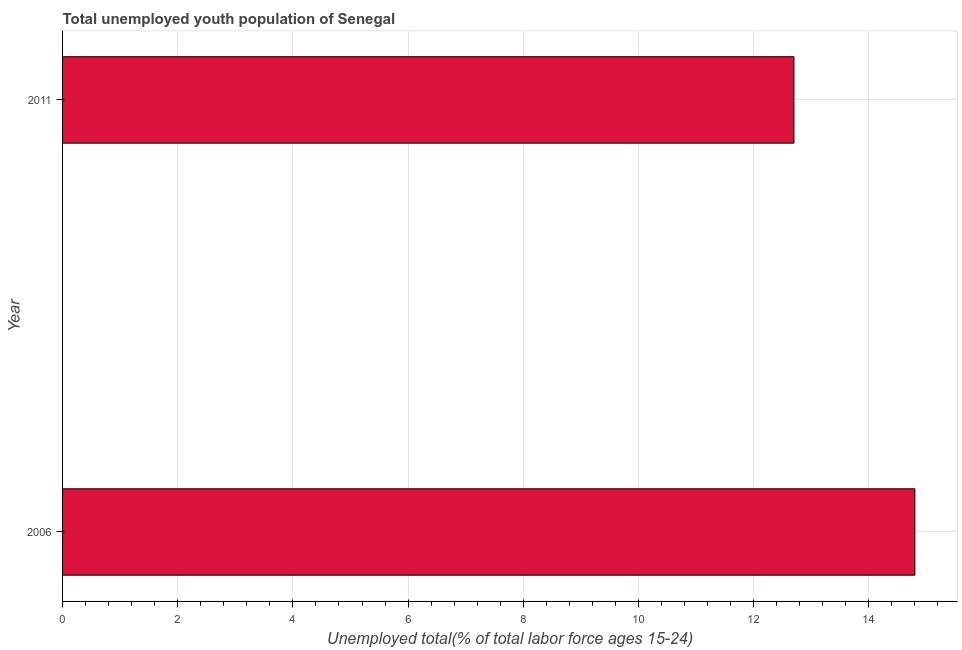Does the graph contain any zero values?
Provide a short and direct response. No. What is the title of the graph?
Offer a very short reply. Total unemployed youth population of Senegal. What is the label or title of the X-axis?
Offer a very short reply. Unemployed total(% of total labor force ages 15-24). What is the label or title of the Y-axis?
Offer a very short reply. Year. What is the unemployed youth in 2011?
Your answer should be compact. 12.7. Across all years, what is the maximum unemployed youth?
Make the answer very short. 14.8. Across all years, what is the minimum unemployed youth?
Offer a terse response. 12.7. In which year was the unemployed youth maximum?
Offer a terse response. 2006. What is the sum of the unemployed youth?
Keep it short and to the point. 27.5. What is the difference between the unemployed youth in 2006 and 2011?
Give a very brief answer. 2.1. What is the average unemployed youth per year?
Provide a short and direct response. 13.75. What is the median unemployed youth?
Your response must be concise. 13.75. In how many years, is the unemployed youth greater than 12.4 %?
Make the answer very short. 2. Do a majority of the years between 2006 and 2011 (inclusive) have unemployed youth greater than 1.6 %?
Provide a succinct answer. Yes. What is the ratio of the unemployed youth in 2006 to that in 2011?
Ensure brevity in your answer.  1.17. In how many years, is the unemployed youth greater than the average unemployed youth taken over all years?
Make the answer very short. 1. Are all the bars in the graph horizontal?
Give a very brief answer. Yes. What is the Unemployed total(% of total labor force ages 15-24) of 2006?
Keep it short and to the point. 14.8. What is the Unemployed total(% of total labor force ages 15-24) of 2011?
Provide a succinct answer. 12.7. What is the difference between the Unemployed total(% of total labor force ages 15-24) in 2006 and 2011?
Offer a very short reply. 2.1. What is the ratio of the Unemployed total(% of total labor force ages 15-24) in 2006 to that in 2011?
Provide a short and direct response. 1.17. 